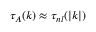Convert formula to latex. <formula><loc_0><loc_0><loc_500><loc_500>\tau _ { A } ( k ) \approx \tau _ { n l } ( | k | )</formula> 